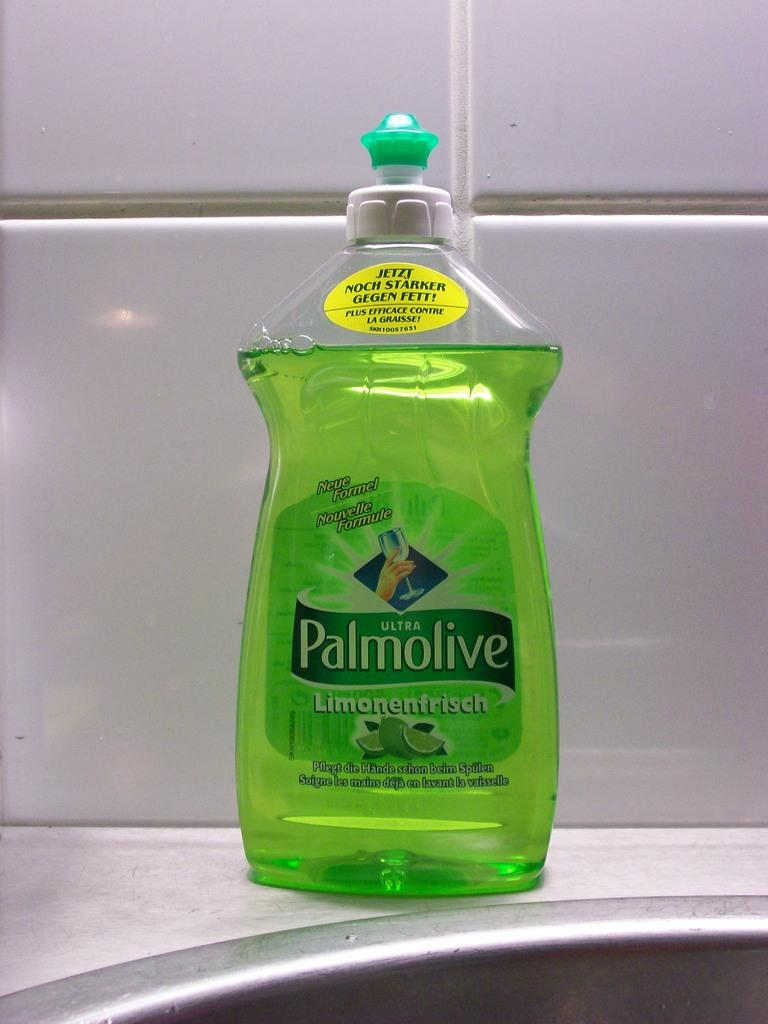What is the main object in the image? There is a dish wash liquid bottle in the image. What can be seen in the background of the image? The background has white-colored tiles. Can you see a needle threaded with thread in the image? No, there is no needle or thread present in the image. What type of carriage is visible in the image? There is no carriage present in the image. 